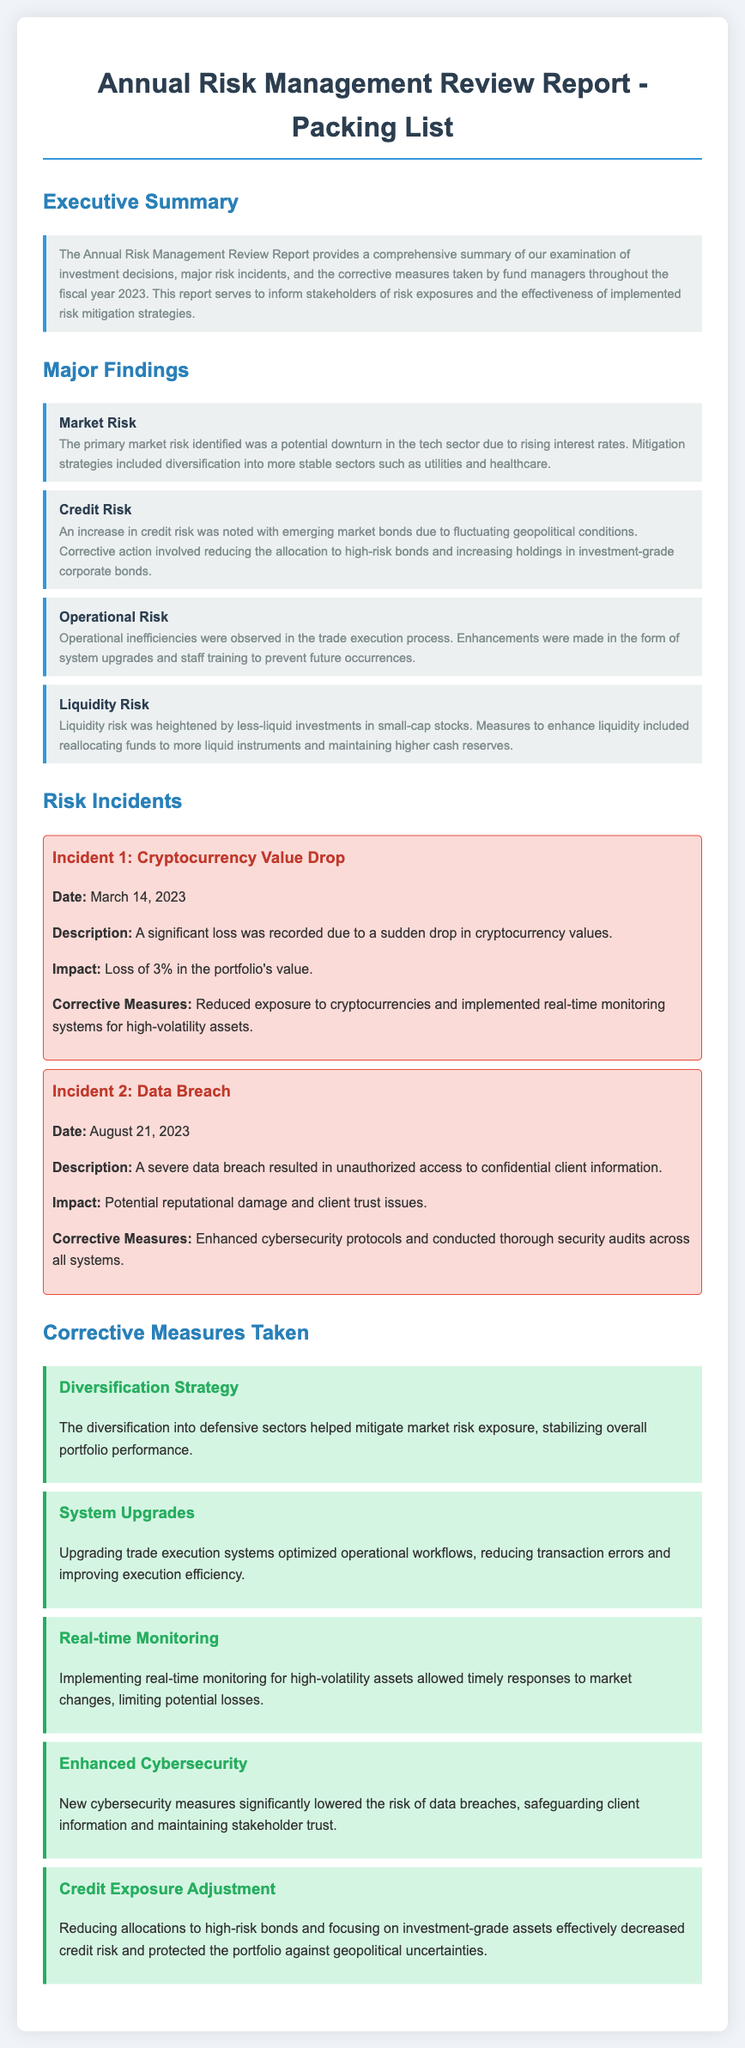What does the report summarize? The report provides a comprehensive summary of examination of investment decisions, major risk incidents, and corrective measures taken by fund managers throughout the fiscal year 2023.
Answer: investment decisions, major risk incidents, and corrective measures What was the primary market risk identified? The primary market risk pertains to the potential downturn in the tech sector due to rising interest rates.
Answer: potential downturn in the tech sector When did the cryptocurrency value drop incident occur? The incident occurred on March 14, 2023, as mentioned in the risk incidents section.
Answer: March 14, 2023 What corrective measure was taken due to the operational inefficiencies? Enhancements were made in the form of system upgrades and staff training.
Answer: system upgrades and staff training How did the diversification strategy help? The diversification into defensive sectors helped mitigate market risk exposure.
Answer: mitigate market risk exposure What was the impact of the data breach incident? The data breach incident led to potential reputational damage and client trust issues.
Answer: potential reputational damage and client trust issues What amount of loss did the cryptocurrency incident cause? The loss recorded due to the cryptocurrency incident was 3% in the portfolio's value.
Answer: 3% What was done to enhance liquidity? Funds were reallocated to more liquid instruments and maintained higher cash reserves.
Answer: reallocating funds to more liquid instruments What is mentioned as a corrective measure for credit risk? Reducing allocations to high-risk bonds and increasing holdings in investment-grade corporate bonds.
Answer: reducing allocations to high-risk bonds 